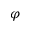Convert formula to latex. <formula><loc_0><loc_0><loc_500><loc_500>\varphi</formula> 